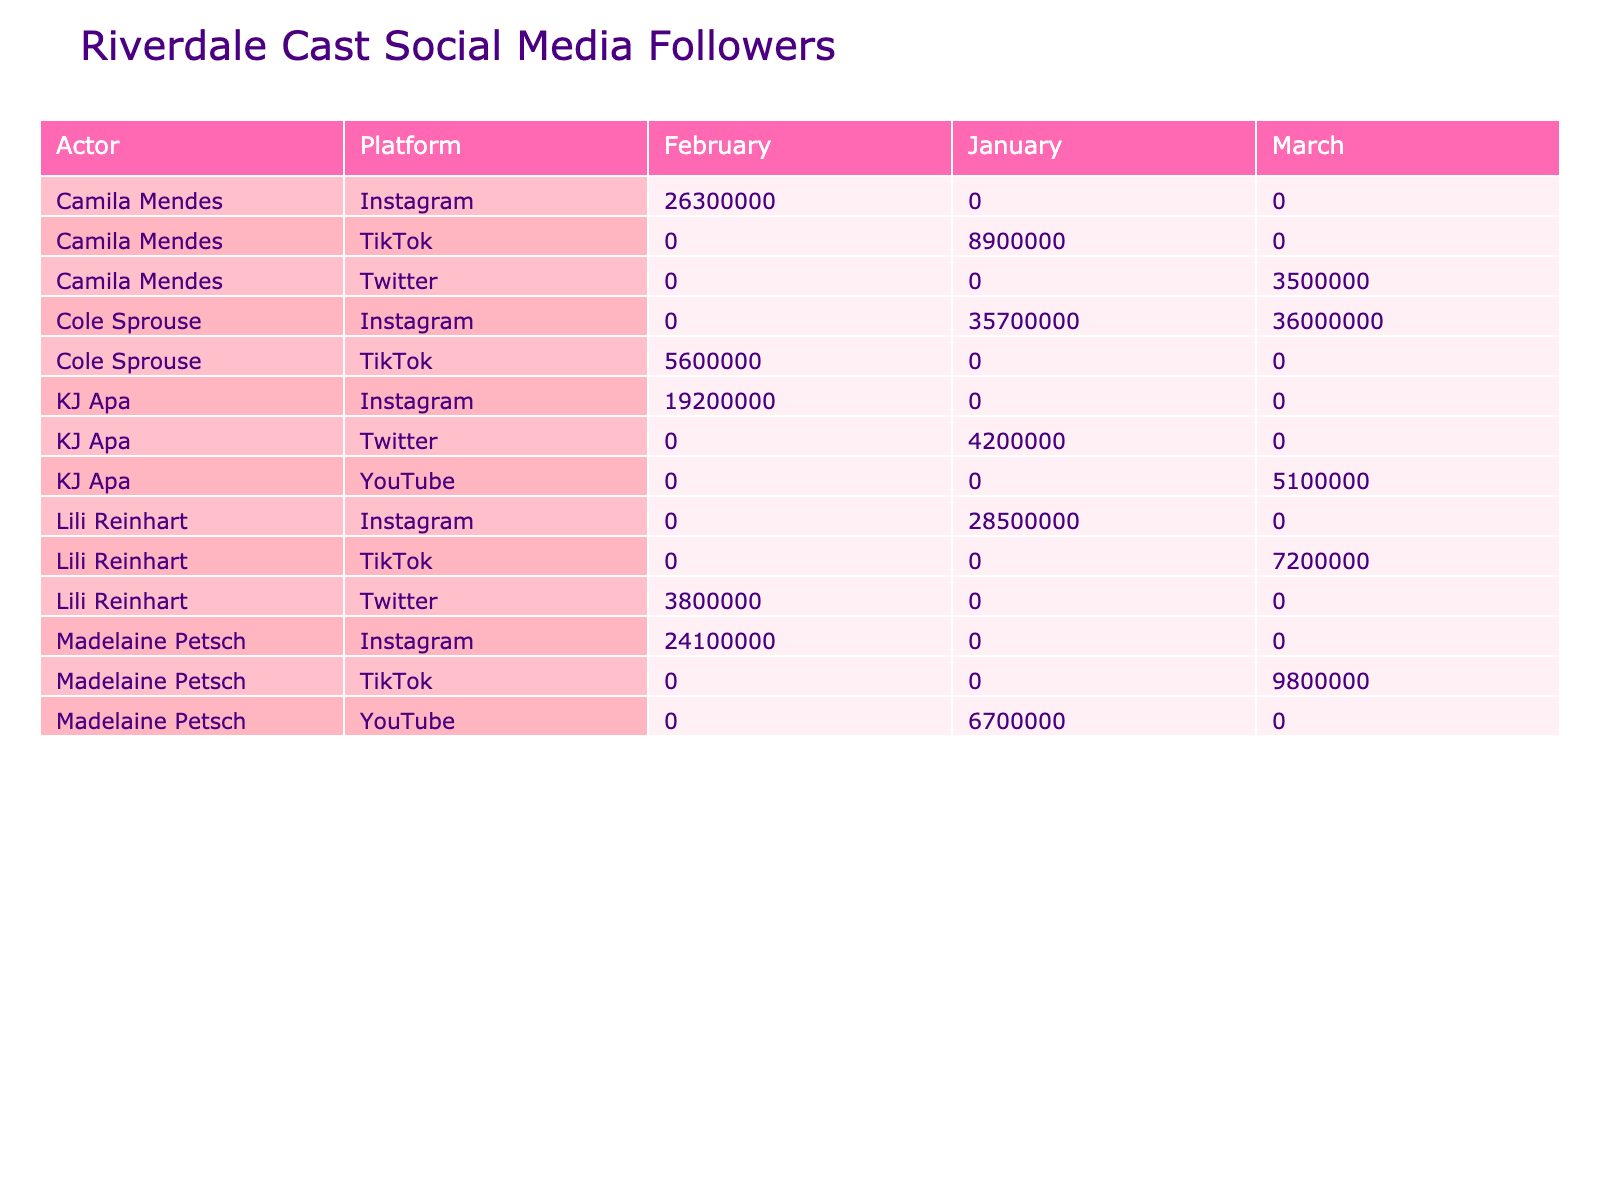What actor has the highest number of Instagram followers in January? Looking at the table, I compare the Instagram followers for each actor in January. Lili Reinhart has 28,500,000 followers and Cole Sprouse has 35,700,000 followers. Cole Sprouse has more followers than Lili Reinhart.
Answer: Cole Sprouse How many followers did KJ Apa gain on Instagram from January to February? KJ Apa had 4,200,000 followers in January and increased to 19,200,000 followers in February. The difference is 19,200,000 - 4,200,000 = 15,000,000 followers gained.
Answer: 15,000,000 Did Madelaine Petsch have any video posts in February? In the table, it shows that Madelaine Petsch's post type in February is 'Photo'. This means she did not have any video posts that month.
Answer: No What is the total number of likes received by Cole Sprouse's posts in January and February? In January, Cole Sprouse received 1,800,000 likes, and in February, he received 1,900,000 likes. The total likes are 1,800,000 + 1,900,000 = 3,700,000 likes.
Answer: 3,700,000 Which platform did Camila Mendes have the highest follower count? By examining the follower counts across different platforms for Camila Mendes, she has 8,900,000 on TikTok, 26,300,000 on Instagram, and 3,500,000 on Twitter. The highest follower count is on Instagram.
Answer: Instagram What percentage of Lili Reinhart's Instagram followers in March compared to her followers in January? Lili Reinhart had 28,500,000 followers in January and 7,200,000 in March. The percentage is calculated as (7,200,000 / 28,500,000) * 100 = 25.26%, meaning her March followers are approximately 25.26% of her January count.
Answer: 25.26% 